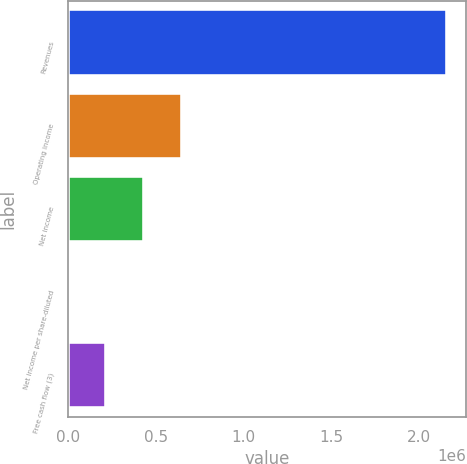<chart> <loc_0><loc_0><loc_500><loc_500><bar_chart><fcel>Revenues<fcel>Operating income<fcel>Net income<fcel>Net income per share-diluted<fcel>Free cash flow (3)<nl><fcel>2.16262e+06<fcel>648790<fcel>432527<fcel>2.96<fcel>216265<nl></chart> 